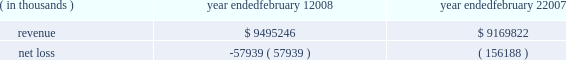For intangible assets subject to amortization , the estimated aggregate amortization expense for each of the five succeeding fiscal years is as follows : 2009 - $ 41.1 million , 2010 - $ 27.3 million , 2011 - $ 20.9 million , 2012 - $ 17.0 million , and 2013 - $ 12.0 million .
Fees and expenses related to the merger totaled $ 102.6 million , principally consisting of investment banking fees , legal fees and stock compensation ( $ 39.4 million as further discussed in note 10 ) , and are reflected in the 2007 results of operations .
Capitalized debt issuance costs as of the merger date of $ 87.4 million for merger-related financing were reflected in other long- term assets in the consolidated balance sheet .
The following represents the unaudited pro forma results of the company 2019s consolidated operations as if the merger had occurred on february 3 , 2007 and february 4 , 2006 , respectively , after giving effect to certain adjustments , including the depreciation and amortization of the assets acquired based on their estimated fair values and changes in interest expense resulting from changes in consolidated debt ( in thousands ) : ( in thousands ) year ended february 1 , year ended february 2 .
The pro forma information does not purport to be indicative of what the company 2019s results of operations would have been if the acquisition had in fact occurred at the beginning of the periods presented , and is not intended to be a projection of the company 2019s future results of operations .
Subsequent to the announcement of the merger agreement , the company and its directors , along with other parties , were named in seven putative class actions filed in tennessee state courts alleging claims for breach of fiduciary duty arising out of the proposed merger , all as described more fully under 201clegal proceedings 201d in note 8 below .
Strategic initiatives during 2006 , the company began implementing certain strategic initiatives related to its historical inventory management and real estate strategies , as more fully described below .
Inventory management in november 2006 , the company undertook an initiative to discontinue its historical inventory packaway model for virtually all merchandise by the end of fiscal 2007 .
Under the packaway model , certain unsold inventory items ( primarily seasonal merchandise ) were stored on-site and returned to the sales floor until the items were eventually sold , damaged or discarded .
Through end-of-season and other markdowns , this initiative resulted in the elimination of seasonal , home products and basic clothing packaway merchandise to allow for increased levels of newer , current-season merchandise .
In connection with this strategic change , in the third quarter of 2006 the company recorded a reserve for lower of cost or market inventory .
What is the net income margin in 2008? 
Computations: (57939 / 9495246)
Answer: 0.0061. 